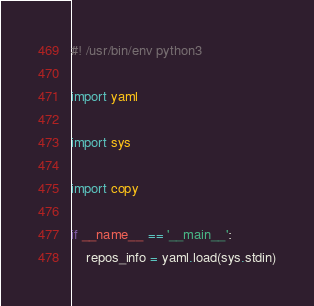Convert code to text. <code><loc_0><loc_0><loc_500><loc_500><_Python_>#! /usr/bin/env python3

import yaml

import sys

import copy

if __name__ == '__main__':
    repos_info = yaml.load(sys.stdin)</code> 